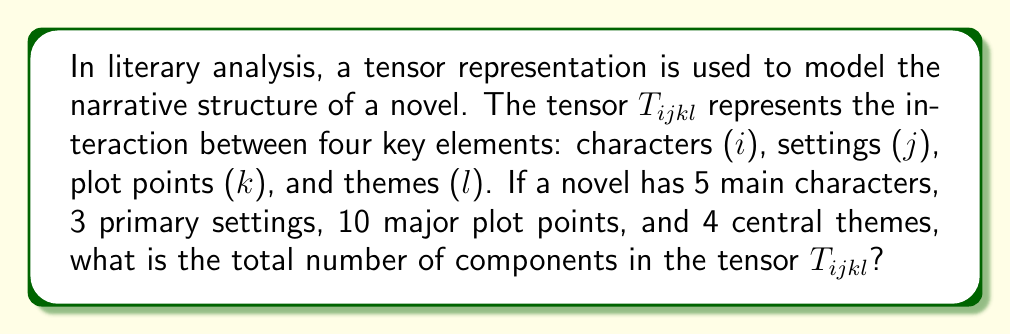Teach me how to tackle this problem. To solve this problem, we need to understand the concept of tensor components and how they relate to the dimensions of the tensor. Let's break it down step-by-step:

1. The tensor $T_{ijkl}$ is a 4th-order tensor, as it has four indices.

2. Each index represents a different aspect of the narrative structure:
   i: characters (5)
   j: settings (3)
   k: plot points (10)
   l: themes (4)

3. The number of components in a tensor is the product of the dimensions of each index. This is because each combination of indices represents a unique component.

4. We can express this mathematically as:

   $$ \text{Number of components} = d_i \times d_j \times d_k \times d_l $$

   Where $d_i$, $d_j$, $d_k$, and $d_l$ are the dimensions of each index.

5. Substituting the given values:

   $$ \text{Number of components} = 5 \times 3 \times 10 \times 4 $$

6. Calculating the result:

   $$ \text{Number of components} = 600 $$

Thus, the tensor $T_{ijkl}$ representing this novel's narrative structure has 600 components.
Answer: 600 